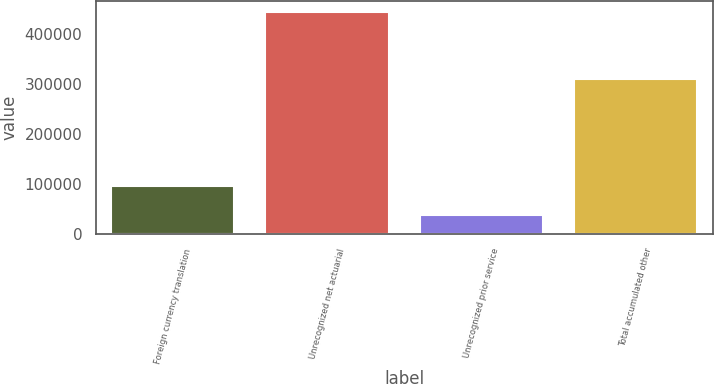Convert chart. <chart><loc_0><loc_0><loc_500><loc_500><bar_chart><fcel>Foreign currency translation<fcel>Unrecognized net actuarial<fcel>Unrecognized prior service<fcel>Total accumulated other<nl><fcel>95513<fcel>444156<fcel>38746<fcel>309897<nl></chart> 